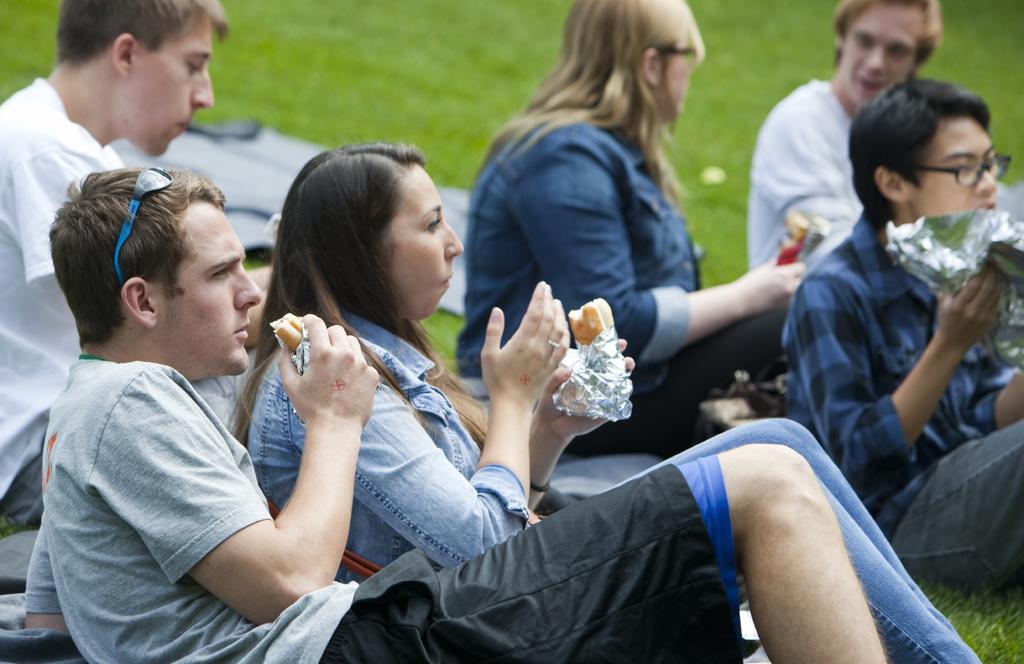Describe this image in one or two sentences. In this image, we can see some people sitting on the grass and they are eating food. 